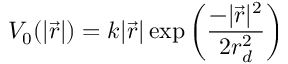Convert formula to latex. <formula><loc_0><loc_0><loc_500><loc_500>V _ { 0 } ( | \vec { r } | ) = k | \vec { r } | \exp { \left ( \frac { - | \vec { r } | ^ { 2 } } { 2 r _ { d } ^ { 2 } } \right ) }</formula> 